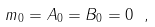<formula> <loc_0><loc_0><loc_500><loc_500>m _ { 0 } = A _ { 0 } = B _ { 0 } = 0 \ ,</formula> 